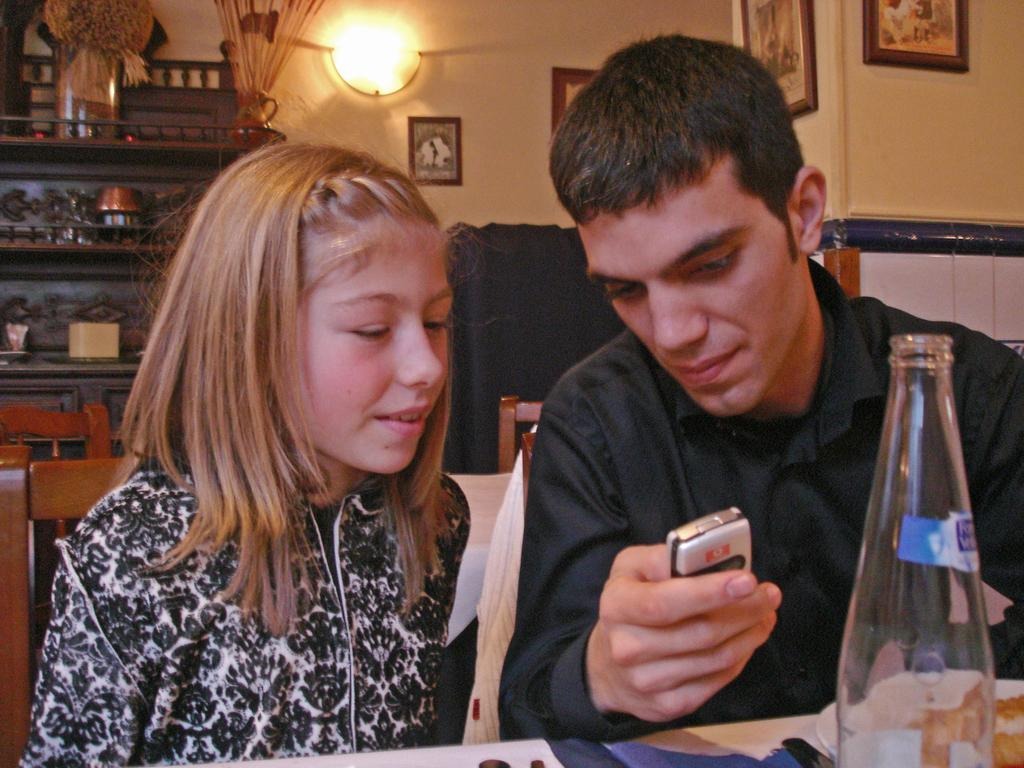What is the man doing in the image? The man is sitting on a chair on the right side of the image and showing something on a mobile phone. Who is sitting next to the man? There is a girl sitting on a chair next to the man. What might the man be showing the girl on the mobile phone? It is not possible to determine exactly what the man is showing the girl on the mobile phone from the image alone. What type of string is being used to connect the man's brain to the girl's sugar intake in the image? There is no string, brain, or sugar present in the image. 